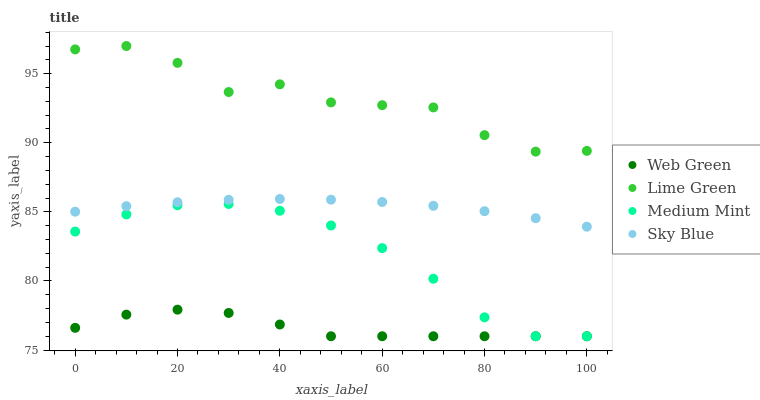Does Web Green have the minimum area under the curve?
Answer yes or no. Yes. Does Lime Green have the maximum area under the curve?
Answer yes or no. Yes. Does Sky Blue have the minimum area under the curve?
Answer yes or no. No. Does Sky Blue have the maximum area under the curve?
Answer yes or no. No. Is Sky Blue the smoothest?
Answer yes or no. Yes. Is Lime Green the roughest?
Answer yes or no. Yes. Is Lime Green the smoothest?
Answer yes or no. No. Is Sky Blue the roughest?
Answer yes or no. No. Does Medium Mint have the lowest value?
Answer yes or no. Yes. Does Sky Blue have the lowest value?
Answer yes or no. No. Does Lime Green have the highest value?
Answer yes or no. Yes. Does Sky Blue have the highest value?
Answer yes or no. No. Is Web Green less than Lime Green?
Answer yes or no. Yes. Is Sky Blue greater than Medium Mint?
Answer yes or no. Yes. Does Web Green intersect Medium Mint?
Answer yes or no. Yes. Is Web Green less than Medium Mint?
Answer yes or no. No. Is Web Green greater than Medium Mint?
Answer yes or no. No. Does Web Green intersect Lime Green?
Answer yes or no. No. 